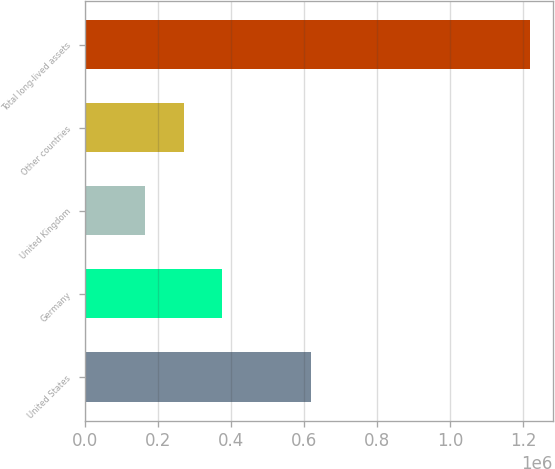Convert chart to OTSL. <chart><loc_0><loc_0><loc_500><loc_500><bar_chart><fcel>United States<fcel>Germany<fcel>United Kingdom<fcel>Other countries<fcel>Total long-lived assets<nl><fcel>620125<fcel>376148<fcel>165145<fcel>270647<fcel>1.22016e+06<nl></chart> 